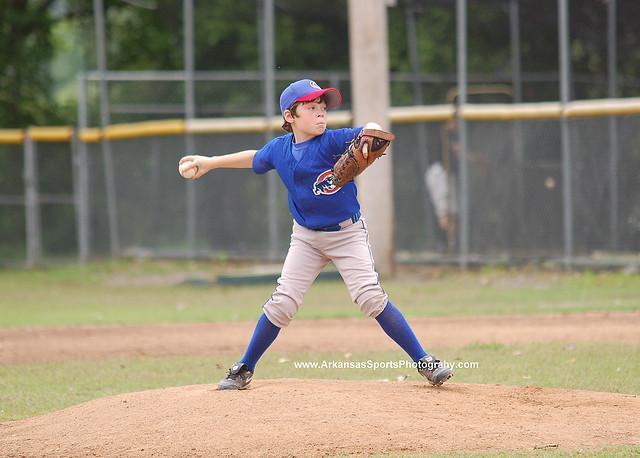How many red suitcases are there in the image?
Give a very brief answer. 0. 